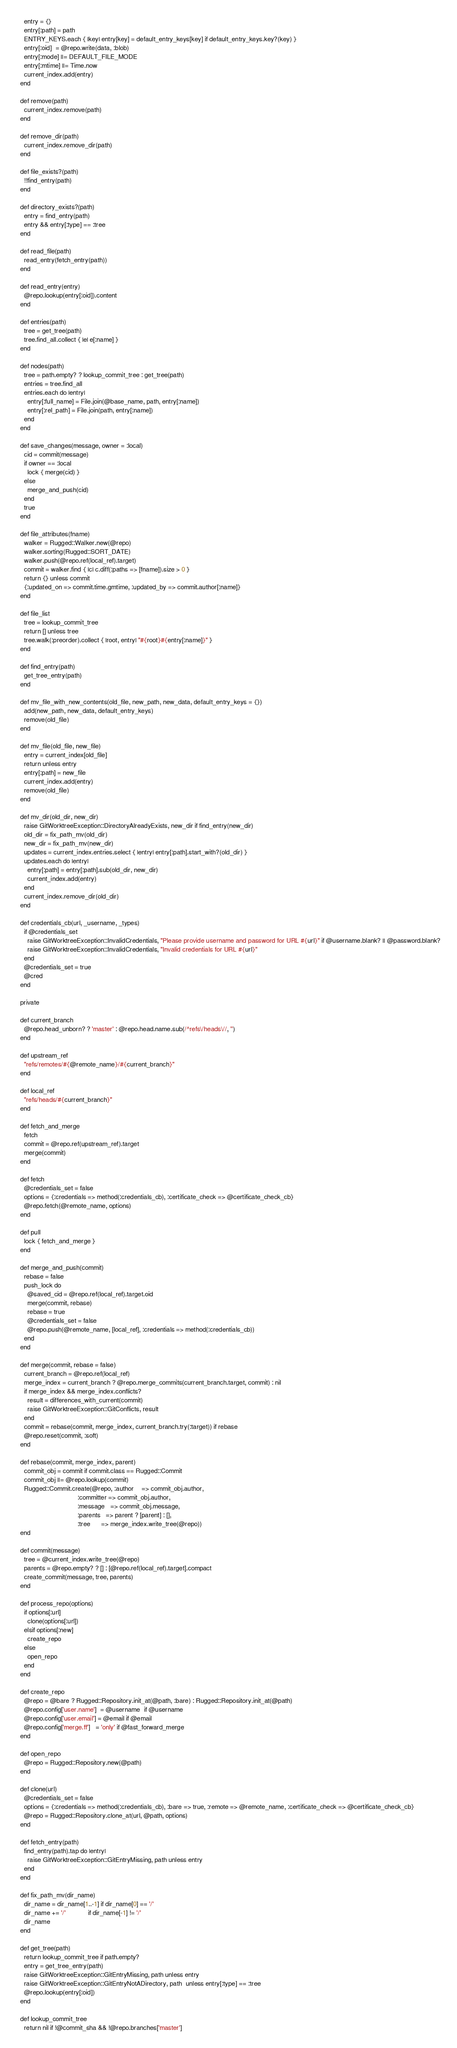<code> <loc_0><loc_0><loc_500><loc_500><_Ruby_>    entry = {}
    entry[:path] = path
    ENTRY_KEYS.each { |key| entry[key] = default_entry_keys[key] if default_entry_keys.key?(key) }
    entry[:oid]  = @repo.write(data, :blob)
    entry[:mode] ||= DEFAULT_FILE_MODE
    entry[:mtime] ||= Time.now
    current_index.add(entry)
  end

  def remove(path)
    current_index.remove(path)
  end

  def remove_dir(path)
    current_index.remove_dir(path)
  end

  def file_exists?(path)
    !!find_entry(path)
  end

  def directory_exists?(path)
    entry = find_entry(path)
    entry && entry[:type] == :tree
  end

  def read_file(path)
    read_entry(fetch_entry(path))
  end

  def read_entry(entry)
    @repo.lookup(entry[:oid]).content
  end

  def entries(path)
    tree = get_tree(path)
    tree.find_all.collect { |e| e[:name] }
  end

  def nodes(path)
    tree = path.empty? ? lookup_commit_tree : get_tree(path)
    entries = tree.find_all
    entries.each do |entry|
      entry[:full_name] = File.join(@base_name, path, entry[:name])
      entry[:rel_path] = File.join(path, entry[:name])
    end
  end

  def save_changes(message, owner = :local)
    cid = commit(message)
    if owner == :local
      lock { merge(cid) }
    else
      merge_and_push(cid)
    end
    true
  end

  def file_attributes(fname)
    walker = Rugged::Walker.new(@repo)
    walker.sorting(Rugged::SORT_DATE)
    walker.push(@repo.ref(local_ref).target)
    commit = walker.find { |c| c.diff(:paths => [fname]).size > 0 }
    return {} unless commit
    {:updated_on => commit.time.gmtime, :updated_by => commit.author[:name]}
  end

  def file_list
    tree = lookup_commit_tree
    return [] unless tree
    tree.walk(:preorder).collect { |root, entry| "#{root}#{entry[:name]}" }
  end

  def find_entry(path)
    get_tree_entry(path)
  end

  def mv_file_with_new_contents(old_file, new_path, new_data, default_entry_keys = {})
    add(new_path, new_data, default_entry_keys)
    remove(old_file)
  end

  def mv_file(old_file, new_file)
    entry = current_index[old_file]
    return unless entry
    entry[:path] = new_file
    current_index.add(entry)
    remove(old_file)
  end

  def mv_dir(old_dir, new_dir)
    raise GitWorktreeException::DirectoryAlreadyExists, new_dir if find_entry(new_dir)
    old_dir = fix_path_mv(old_dir)
    new_dir = fix_path_mv(new_dir)
    updates = current_index.entries.select { |entry| entry[:path].start_with?(old_dir) }
    updates.each do |entry|
      entry[:path] = entry[:path].sub(old_dir, new_dir)
      current_index.add(entry)
    end
    current_index.remove_dir(old_dir)
  end

  def credentials_cb(url, _username, _types)
    if @credentials_set
      raise GitWorktreeException::InvalidCredentials, "Please provide username and password for URL #{url}" if @username.blank? || @password.blank?
      raise GitWorktreeException::InvalidCredentials, "Invalid credentials for URL #{url}"
    end
    @credentials_set = true
    @cred
  end

  private

  def current_branch
    @repo.head_unborn? ? 'master' : @repo.head.name.sub(/^refs\/heads\//, '')
  end

  def upstream_ref
    "refs/remotes/#{@remote_name}/#{current_branch}"
  end

  def local_ref
    "refs/heads/#{current_branch}"
  end

  def fetch_and_merge
    fetch
    commit = @repo.ref(upstream_ref).target
    merge(commit)
  end

  def fetch
    @credentials_set = false
    options = {:credentials => method(:credentials_cb), :certificate_check => @certificate_check_cb}
    @repo.fetch(@remote_name, options)
  end

  def pull
    lock { fetch_and_merge }
  end

  def merge_and_push(commit)
    rebase = false
    push_lock do
      @saved_cid = @repo.ref(local_ref).target.oid
      merge(commit, rebase)
      rebase = true
      @credentials_set = false
      @repo.push(@remote_name, [local_ref], :credentials => method(:credentials_cb))
    end
  end

  def merge(commit, rebase = false)
    current_branch = @repo.ref(local_ref)
    merge_index = current_branch ? @repo.merge_commits(current_branch.target, commit) : nil
    if merge_index && merge_index.conflicts?
      result = differences_with_current(commit)
      raise GitWorktreeException::GitConflicts, result
    end
    commit = rebase(commit, merge_index, current_branch.try(:target)) if rebase
    @repo.reset(commit, :soft)
  end

  def rebase(commit, merge_index, parent)
    commit_obj = commit if commit.class == Rugged::Commit
    commit_obj ||= @repo.lookup(commit)
    Rugged::Commit.create(@repo, :author    => commit_obj.author,
                                 :committer => commit_obj.author,
                                 :message   => commit_obj.message,
                                 :parents   => parent ? [parent] : [],
                                 :tree      => merge_index.write_tree(@repo))
  end

  def commit(message)
    tree = @current_index.write_tree(@repo)
    parents = @repo.empty? ? [] : [@repo.ref(local_ref).target].compact
    create_commit(message, tree, parents)
  end

  def process_repo(options)
    if options[:url]
      clone(options[:url])
    elsif options[:new]
      create_repo
    else
      open_repo
    end
  end

  def create_repo
    @repo = @bare ? Rugged::Repository.init_at(@path, :bare) : Rugged::Repository.init_at(@path)
    @repo.config['user.name']  = @username  if @username
    @repo.config['user.email'] = @email if @email
    @repo.config['merge.ff']   = 'only' if @fast_forward_merge
  end

  def open_repo
    @repo = Rugged::Repository.new(@path)
  end

  def clone(url)
    @credentials_set = false
    options = {:credentials => method(:credentials_cb), :bare => true, :remote => @remote_name, :certificate_check => @certificate_check_cb}
    @repo = Rugged::Repository.clone_at(url, @path, options)
  end

  def fetch_entry(path)
    find_entry(path).tap do |entry|
      raise GitWorktreeException::GitEntryMissing, path unless entry
    end
  end

  def fix_path_mv(dir_name)
    dir_name = dir_name[1..-1] if dir_name[0] == '/'
    dir_name += '/'            if dir_name[-1] != '/'
    dir_name
  end

  def get_tree(path)
    return lookup_commit_tree if path.empty?
    entry = get_tree_entry(path)
    raise GitWorktreeException::GitEntryMissing, path unless entry
    raise GitWorktreeException::GitEntryNotADirectory, path  unless entry[:type] == :tree
    @repo.lookup(entry[:oid])
  end

  def lookup_commit_tree
    return nil if !@commit_sha && !@repo.branches['master']</code> 